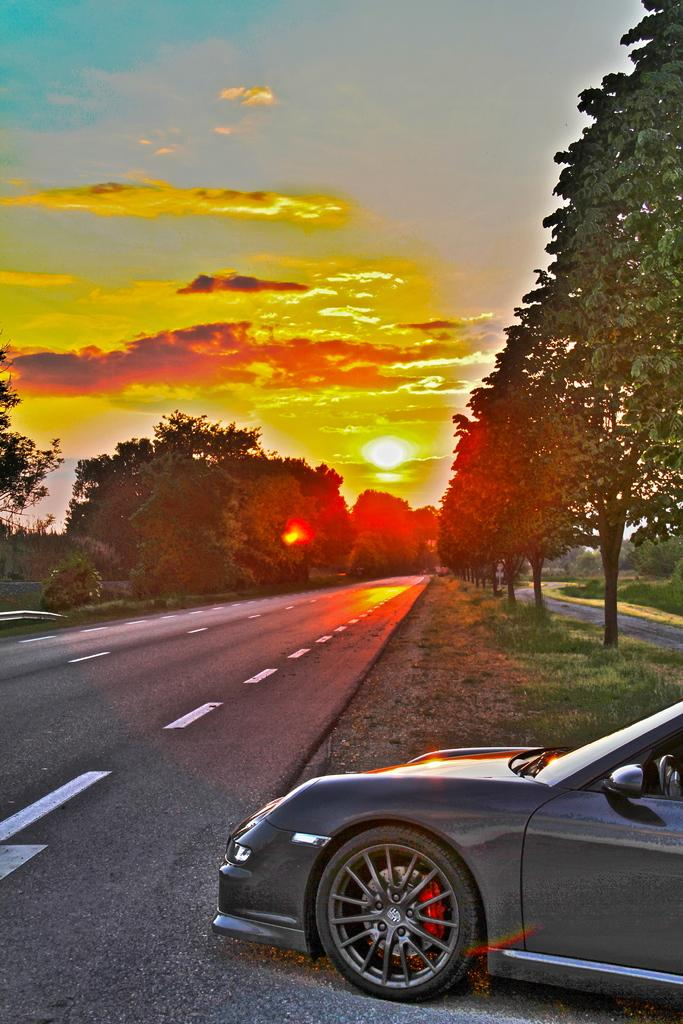What is located on the right side of the image? There is a vehicle on the right side of the image. What can be seen beneath the vehicle? There is a road in the image. What type of vegetation is present in the image? There are trees in the image. What is visible in the sky in the image? Clouds are visible in the sky. What color is the grass in the image? Green grass is present in the image. Can you hear the gunshots in the image? There is no gun or gunshots present in the image; it only features a vehicle, a road, trees, clouds, and green grass. 